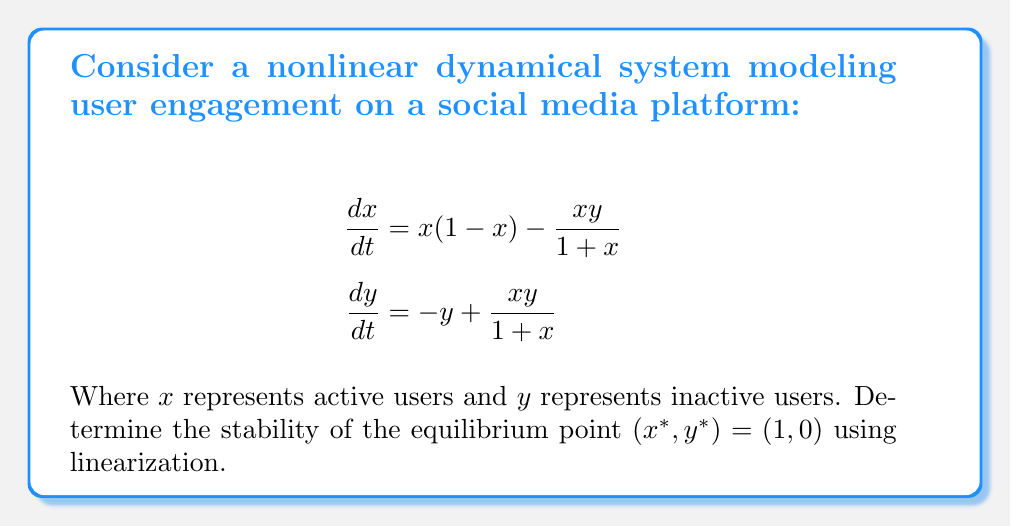Can you answer this question? To determine the stability of the equilibrium point, we need to follow these steps:

1. Calculate the Jacobian matrix at the equilibrium point:
   The Jacobian matrix is given by:
   $$J = \begin{bmatrix}
   \frac{\partial f_1}{\partial x} & \frac{\partial f_1}{\partial y} \\
   \frac{\partial f_2}{\partial x} & \frac{\partial f_2}{\partial y}
   \end{bmatrix}$$

   Where $f_1 = x(1-x) - \frac{xy}{1+x}$ and $f_2 = -y + \frac{xy}{1+x}$

2. Compute the partial derivatives:
   $$\frac{\partial f_1}{\partial x} = 1 - 2x - \frac{y}{(1+x)^2}$$
   $$\frac{\partial f_1}{\partial y} = -\frac{x}{1+x}$$
   $$\frac{\partial f_2}{\partial x} = \frac{y}{(1+x)^2}$$
   $$\frac{\partial f_2}{\partial y} = -1 + \frac{x}{1+x}$$

3. Evaluate the Jacobian at the equilibrium point $(1, 0)$:
   $$J(1,0) = \begin{bmatrix}
   -1 & -\frac{1}{2} \\
   0 & -\frac{1}{2}
   \end{bmatrix}$$

4. Find the eigenvalues of the Jacobian:
   Characteristic equation: $\det(J - \lambda I) = 0$
   $$\begin{vmatrix}
   -1 - \lambda & -\frac{1}{2} \\
   0 & -\frac{1}{2} - \lambda
   \end{vmatrix} = 0$$
   
   $(-1 - \lambda)(-\frac{1}{2} - \lambda) = 0$
   
   Eigenvalues: $\lambda_1 = -1$, $\lambda_2 = -\frac{1}{2}$

5. Analyze the stability:
   Both eigenvalues are real and negative, which indicates that the equilibrium point $(1, 0)$ is asymptotically stable.
Answer: Asymptotically stable 